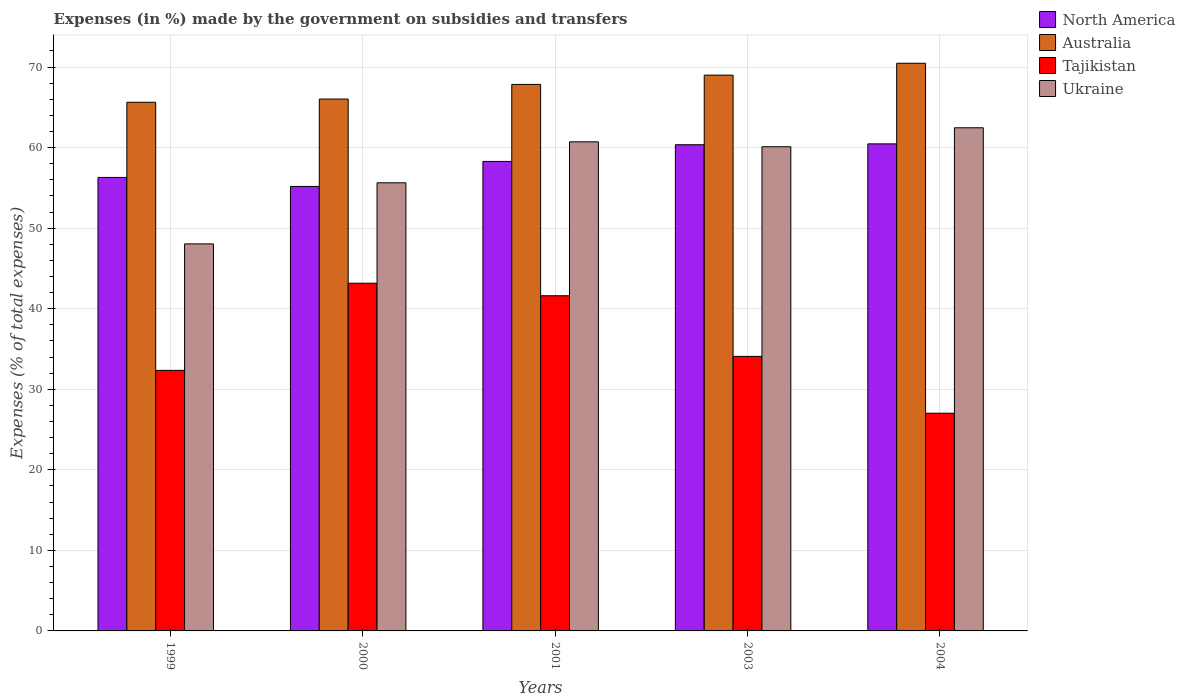In how many cases, is the number of bars for a given year not equal to the number of legend labels?
Ensure brevity in your answer.  0. What is the percentage of expenses made by the government on subsidies and transfers in Tajikistan in 2004?
Offer a very short reply. 27.03. Across all years, what is the maximum percentage of expenses made by the government on subsidies and transfers in Tajikistan?
Give a very brief answer. 43.16. Across all years, what is the minimum percentage of expenses made by the government on subsidies and transfers in Tajikistan?
Keep it short and to the point. 27.03. In which year was the percentage of expenses made by the government on subsidies and transfers in Tajikistan maximum?
Offer a very short reply. 2000. What is the total percentage of expenses made by the government on subsidies and transfers in Tajikistan in the graph?
Keep it short and to the point. 178.21. What is the difference between the percentage of expenses made by the government on subsidies and transfers in Tajikistan in 2003 and that in 2004?
Your response must be concise. 7.05. What is the difference between the percentage of expenses made by the government on subsidies and transfers in Tajikistan in 2003 and the percentage of expenses made by the government on subsidies and transfers in Ukraine in 1999?
Provide a succinct answer. -13.97. What is the average percentage of expenses made by the government on subsidies and transfers in North America per year?
Offer a terse response. 58.11. In the year 2004, what is the difference between the percentage of expenses made by the government on subsidies and transfers in Ukraine and percentage of expenses made by the government on subsidies and transfers in North America?
Your answer should be very brief. 2. In how many years, is the percentage of expenses made by the government on subsidies and transfers in North America greater than 40 %?
Make the answer very short. 5. What is the ratio of the percentage of expenses made by the government on subsidies and transfers in Australia in 1999 to that in 2000?
Your answer should be very brief. 0.99. What is the difference between the highest and the second highest percentage of expenses made by the government on subsidies and transfers in Tajikistan?
Give a very brief answer. 1.56. What is the difference between the highest and the lowest percentage of expenses made by the government on subsidies and transfers in Tajikistan?
Provide a short and direct response. 16.14. Is the sum of the percentage of expenses made by the government on subsidies and transfers in North America in 1999 and 2003 greater than the maximum percentage of expenses made by the government on subsidies and transfers in Australia across all years?
Offer a very short reply. Yes. What does the 4th bar from the left in 2001 represents?
Make the answer very short. Ukraine. What does the 2nd bar from the right in 2004 represents?
Ensure brevity in your answer.  Tajikistan. Is it the case that in every year, the sum of the percentage of expenses made by the government on subsidies and transfers in North America and percentage of expenses made by the government on subsidies and transfers in Australia is greater than the percentage of expenses made by the government on subsidies and transfers in Tajikistan?
Offer a terse response. Yes. How many bars are there?
Ensure brevity in your answer.  20. How many years are there in the graph?
Keep it short and to the point. 5. What is the difference between two consecutive major ticks on the Y-axis?
Your answer should be very brief. 10. Are the values on the major ticks of Y-axis written in scientific E-notation?
Ensure brevity in your answer.  No. Does the graph contain grids?
Ensure brevity in your answer.  Yes. How are the legend labels stacked?
Give a very brief answer. Vertical. What is the title of the graph?
Provide a succinct answer. Expenses (in %) made by the government on subsidies and transfers. Does "Namibia" appear as one of the legend labels in the graph?
Offer a terse response. No. What is the label or title of the Y-axis?
Give a very brief answer. Expenses (% of total expenses). What is the Expenses (% of total expenses) of North America in 1999?
Your answer should be compact. 56.29. What is the Expenses (% of total expenses) of Australia in 1999?
Your response must be concise. 65.63. What is the Expenses (% of total expenses) of Tajikistan in 1999?
Give a very brief answer. 32.34. What is the Expenses (% of total expenses) in Ukraine in 1999?
Ensure brevity in your answer.  48.04. What is the Expenses (% of total expenses) of North America in 2000?
Give a very brief answer. 55.18. What is the Expenses (% of total expenses) of Australia in 2000?
Give a very brief answer. 66.02. What is the Expenses (% of total expenses) of Tajikistan in 2000?
Provide a short and direct response. 43.16. What is the Expenses (% of total expenses) of Ukraine in 2000?
Offer a very short reply. 55.63. What is the Expenses (% of total expenses) of North America in 2001?
Make the answer very short. 58.28. What is the Expenses (% of total expenses) of Australia in 2001?
Offer a very short reply. 67.84. What is the Expenses (% of total expenses) in Tajikistan in 2001?
Provide a short and direct response. 41.61. What is the Expenses (% of total expenses) in Ukraine in 2001?
Make the answer very short. 60.71. What is the Expenses (% of total expenses) in North America in 2003?
Ensure brevity in your answer.  60.35. What is the Expenses (% of total expenses) of Australia in 2003?
Ensure brevity in your answer.  68.99. What is the Expenses (% of total expenses) in Tajikistan in 2003?
Give a very brief answer. 34.08. What is the Expenses (% of total expenses) in Ukraine in 2003?
Your answer should be compact. 60.1. What is the Expenses (% of total expenses) in North America in 2004?
Offer a very short reply. 60.46. What is the Expenses (% of total expenses) in Australia in 2004?
Give a very brief answer. 70.47. What is the Expenses (% of total expenses) in Tajikistan in 2004?
Keep it short and to the point. 27.03. What is the Expenses (% of total expenses) of Ukraine in 2004?
Your answer should be very brief. 62.46. Across all years, what is the maximum Expenses (% of total expenses) of North America?
Provide a short and direct response. 60.46. Across all years, what is the maximum Expenses (% of total expenses) in Australia?
Ensure brevity in your answer.  70.47. Across all years, what is the maximum Expenses (% of total expenses) of Tajikistan?
Offer a terse response. 43.16. Across all years, what is the maximum Expenses (% of total expenses) of Ukraine?
Give a very brief answer. 62.46. Across all years, what is the minimum Expenses (% of total expenses) in North America?
Offer a terse response. 55.18. Across all years, what is the minimum Expenses (% of total expenses) in Australia?
Provide a short and direct response. 65.63. Across all years, what is the minimum Expenses (% of total expenses) in Tajikistan?
Your answer should be very brief. 27.03. Across all years, what is the minimum Expenses (% of total expenses) of Ukraine?
Provide a succinct answer. 48.04. What is the total Expenses (% of total expenses) in North America in the graph?
Provide a short and direct response. 290.56. What is the total Expenses (% of total expenses) in Australia in the graph?
Your answer should be compact. 338.95. What is the total Expenses (% of total expenses) of Tajikistan in the graph?
Give a very brief answer. 178.21. What is the total Expenses (% of total expenses) in Ukraine in the graph?
Offer a very short reply. 286.95. What is the difference between the Expenses (% of total expenses) of North America in 1999 and that in 2000?
Make the answer very short. 1.12. What is the difference between the Expenses (% of total expenses) of Australia in 1999 and that in 2000?
Ensure brevity in your answer.  -0.4. What is the difference between the Expenses (% of total expenses) of Tajikistan in 1999 and that in 2000?
Give a very brief answer. -10.82. What is the difference between the Expenses (% of total expenses) of Ukraine in 1999 and that in 2000?
Keep it short and to the point. -7.59. What is the difference between the Expenses (% of total expenses) of North America in 1999 and that in 2001?
Offer a very short reply. -1.99. What is the difference between the Expenses (% of total expenses) of Australia in 1999 and that in 2001?
Keep it short and to the point. -2.21. What is the difference between the Expenses (% of total expenses) of Tajikistan in 1999 and that in 2001?
Your answer should be compact. -9.27. What is the difference between the Expenses (% of total expenses) of Ukraine in 1999 and that in 2001?
Give a very brief answer. -12.67. What is the difference between the Expenses (% of total expenses) of North America in 1999 and that in 2003?
Keep it short and to the point. -4.06. What is the difference between the Expenses (% of total expenses) in Australia in 1999 and that in 2003?
Your response must be concise. -3.37. What is the difference between the Expenses (% of total expenses) of Tajikistan in 1999 and that in 2003?
Your answer should be compact. -1.74. What is the difference between the Expenses (% of total expenses) of Ukraine in 1999 and that in 2003?
Make the answer very short. -12.06. What is the difference between the Expenses (% of total expenses) in North America in 1999 and that in 2004?
Provide a short and direct response. -4.17. What is the difference between the Expenses (% of total expenses) of Australia in 1999 and that in 2004?
Your response must be concise. -4.84. What is the difference between the Expenses (% of total expenses) of Tajikistan in 1999 and that in 2004?
Your response must be concise. 5.32. What is the difference between the Expenses (% of total expenses) of Ukraine in 1999 and that in 2004?
Your answer should be compact. -14.41. What is the difference between the Expenses (% of total expenses) of North America in 2000 and that in 2001?
Your response must be concise. -3.1. What is the difference between the Expenses (% of total expenses) of Australia in 2000 and that in 2001?
Ensure brevity in your answer.  -1.82. What is the difference between the Expenses (% of total expenses) in Tajikistan in 2000 and that in 2001?
Provide a short and direct response. 1.56. What is the difference between the Expenses (% of total expenses) of Ukraine in 2000 and that in 2001?
Provide a succinct answer. -5.08. What is the difference between the Expenses (% of total expenses) in North America in 2000 and that in 2003?
Provide a succinct answer. -5.18. What is the difference between the Expenses (% of total expenses) in Australia in 2000 and that in 2003?
Keep it short and to the point. -2.97. What is the difference between the Expenses (% of total expenses) of Tajikistan in 2000 and that in 2003?
Your response must be concise. 9.09. What is the difference between the Expenses (% of total expenses) of Ukraine in 2000 and that in 2003?
Offer a terse response. -4.47. What is the difference between the Expenses (% of total expenses) in North America in 2000 and that in 2004?
Your answer should be compact. -5.29. What is the difference between the Expenses (% of total expenses) in Australia in 2000 and that in 2004?
Your answer should be compact. -4.44. What is the difference between the Expenses (% of total expenses) in Tajikistan in 2000 and that in 2004?
Make the answer very short. 16.14. What is the difference between the Expenses (% of total expenses) in Ukraine in 2000 and that in 2004?
Give a very brief answer. -6.83. What is the difference between the Expenses (% of total expenses) of North America in 2001 and that in 2003?
Your response must be concise. -2.07. What is the difference between the Expenses (% of total expenses) in Australia in 2001 and that in 2003?
Keep it short and to the point. -1.15. What is the difference between the Expenses (% of total expenses) of Tajikistan in 2001 and that in 2003?
Provide a succinct answer. 7.53. What is the difference between the Expenses (% of total expenses) in Ukraine in 2001 and that in 2003?
Your answer should be compact. 0.61. What is the difference between the Expenses (% of total expenses) in North America in 2001 and that in 2004?
Your response must be concise. -2.18. What is the difference between the Expenses (% of total expenses) in Australia in 2001 and that in 2004?
Your answer should be compact. -2.63. What is the difference between the Expenses (% of total expenses) in Tajikistan in 2001 and that in 2004?
Ensure brevity in your answer.  14.58. What is the difference between the Expenses (% of total expenses) in Ukraine in 2001 and that in 2004?
Your answer should be very brief. -1.75. What is the difference between the Expenses (% of total expenses) of North America in 2003 and that in 2004?
Ensure brevity in your answer.  -0.11. What is the difference between the Expenses (% of total expenses) in Australia in 2003 and that in 2004?
Offer a terse response. -1.47. What is the difference between the Expenses (% of total expenses) in Tajikistan in 2003 and that in 2004?
Offer a very short reply. 7.05. What is the difference between the Expenses (% of total expenses) in Ukraine in 2003 and that in 2004?
Make the answer very short. -2.36. What is the difference between the Expenses (% of total expenses) in North America in 1999 and the Expenses (% of total expenses) in Australia in 2000?
Your response must be concise. -9.73. What is the difference between the Expenses (% of total expenses) of North America in 1999 and the Expenses (% of total expenses) of Tajikistan in 2000?
Provide a succinct answer. 13.13. What is the difference between the Expenses (% of total expenses) of North America in 1999 and the Expenses (% of total expenses) of Ukraine in 2000?
Keep it short and to the point. 0.66. What is the difference between the Expenses (% of total expenses) of Australia in 1999 and the Expenses (% of total expenses) of Tajikistan in 2000?
Keep it short and to the point. 22.46. What is the difference between the Expenses (% of total expenses) in Australia in 1999 and the Expenses (% of total expenses) in Ukraine in 2000?
Give a very brief answer. 10. What is the difference between the Expenses (% of total expenses) in Tajikistan in 1999 and the Expenses (% of total expenses) in Ukraine in 2000?
Keep it short and to the point. -23.29. What is the difference between the Expenses (% of total expenses) of North America in 1999 and the Expenses (% of total expenses) of Australia in 2001?
Make the answer very short. -11.55. What is the difference between the Expenses (% of total expenses) in North America in 1999 and the Expenses (% of total expenses) in Tajikistan in 2001?
Provide a short and direct response. 14.69. What is the difference between the Expenses (% of total expenses) in North America in 1999 and the Expenses (% of total expenses) in Ukraine in 2001?
Give a very brief answer. -4.42. What is the difference between the Expenses (% of total expenses) in Australia in 1999 and the Expenses (% of total expenses) in Tajikistan in 2001?
Provide a short and direct response. 24.02. What is the difference between the Expenses (% of total expenses) of Australia in 1999 and the Expenses (% of total expenses) of Ukraine in 2001?
Offer a very short reply. 4.91. What is the difference between the Expenses (% of total expenses) in Tajikistan in 1999 and the Expenses (% of total expenses) in Ukraine in 2001?
Provide a succinct answer. -28.37. What is the difference between the Expenses (% of total expenses) in North America in 1999 and the Expenses (% of total expenses) in Australia in 2003?
Offer a terse response. -12.7. What is the difference between the Expenses (% of total expenses) of North America in 1999 and the Expenses (% of total expenses) of Tajikistan in 2003?
Your answer should be compact. 22.22. What is the difference between the Expenses (% of total expenses) in North America in 1999 and the Expenses (% of total expenses) in Ukraine in 2003?
Ensure brevity in your answer.  -3.81. What is the difference between the Expenses (% of total expenses) in Australia in 1999 and the Expenses (% of total expenses) in Tajikistan in 2003?
Offer a very short reply. 31.55. What is the difference between the Expenses (% of total expenses) in Australia in 1999 and the Expenses (% of total expenses) in Ukraine in 2003?
Your answer should be compact. 5.52. What is the difference between the Expenses (% of total expenses) in Tajikistan in 1999 and the Expenses (% of total expenses) in Ukraine in 2003?
Your response must be concise. -27.76. What is the difference between the Expenses (% of total expenses) of North America in 1999 and the Expenses (% of total expenses) of Australia in 2004?
Your answer should be compact. -14.17. What is the difference between the Expenses (% of total expenses) in North America in 1999 and the Expenses (% of total expenses) in Tajikistan in 2004?
Ensure brevity in your answer.  29.27. What is the difference between the Expenses (% of total expenses) of North America in 1999 and the Expenses (% of total expenses) of Ukraine in 2004?
Give a very brief answer. -6.17. What is the difference between the Expenses (% of total expenses) of Australia in 1999 and the Expenses (% of total expenses) of Tajikistan in 2004?
Offer a very short reply. 38.6. What is the difference between the Expenses (% of total expenses) of Australia in 1999 and the Expenses (% of total expenses) of Ukraine in 2004?
Your answer should be very brief. 3.17. What is the difference between the Expenses (% of total expenses) of Tajikistan in 1999 and the Expenses (% of total expenses) of Ukraine in 2004?
Provide a succinct answer. -30.12. What is the difference between the Expenses (% of total expenses) in North America in 2000 and the Expenses (% of total expenses) in Australia in 2001?
Your answer should be compact. -12.67. What is the difference between the Expenses (% of total expenses) in North America in 2000 and the Expenses (% of total expenses) in Tajikistan in 2001?
Your answer should be compact. 13.57. What is the difference between the Expenses (% of total expenses) of North America in 2000 and the Expenses (% of total expenses) of Ukraine in 2001?
Provide a short and direct response. -5.54. What is the difference between the Expenses (% of total expenses) in Australia in 2000 and the Expenses (% of total expenses) in Tajikistan in 2001?
Make the answer very short. 24.42. What is the difference between the Expenses (% of total expenses) of Australia in 2000 and the Expenses (% of total expenses) of Ukraine in 2001?
Provide a short and direct response. 5.31. What is the difference between the Expenses (% of total expenses) in Tajikistan in 2000 and the Expenses (% of total expenses) in Ukraine in 2001?
Keep it short and to the point. -17.55. What is the difference between the Expenses (% of total expenses) of North America in 2000 and the Expenses (% of total expenses) of Australia in 2003?
Offer a very short reply. -13.82. What is the difference between the Expenses (% of total expenses) of North America in 2000 and the Expenses (% of total expenses) of Tajikistan in 2003?
Make the answer very short. 21.1. What is the difference between the Expenses (% of total expenses) in North America in 2000 and the Expenses (% of total expenses) in Ukraine in 2003?
Provide a succinct answer. -4.93. What is the difference between the Expenses (% of total expenses) in Australia in 2000 and the Expenses (% of total expenses) in Tajikistan in 2003?
Keep it short and to the point. 31.95. What is the difference between the Expenses (% of total expenses) of Australia in 2000 and the Expenses (% of total expenses) of Ukraine in 2003?
Give a very brief answer. 5.92. What is the difference between the Expenses (% of total expenses) in Tajikistan in 2000 and the Expenses (% of total expenses) in Ukraine in 2003?
Your response must be concise. -16.94. What is the difference between the Expenses (% of total expenses) in North America in 2000 and the Expenses (% of total expenses) in Australia in 2004?
Make the answer very short. -15.29. What is the difference between the Expenses (% of total expenses) in North America in 2000 and the Expenses (% of total expenses) in Tajikistan in 2004?
Your answer should be very brief. 28.15. What is the difference between the Expenses (% of total expenses) of North America in 2000 and the Expenses (% of total expenses) of Ukraine in 2004?
Your answer should be very brief. -7.28. What is the difference between the Expenses (% of total expenses) of Australia in 2000 and the Expenses (% of total expenses) of Tajikistan in 2004?
Your answer should be very brief. 39. What is the difference between the Expenses (% of total expenses) of Australia in 2000 and the Expenses (% of total expenses) of Ukraine in 2004?
Offer a terse response. 3.57. What is the difference between the Expenses (% of total expenses) of Tajikistan in 2000 and the Expenses (% of total expenses) of Ukraine in 2004?
Make the answer very short. -19.3. What is the difference between the Expenses (% of total expenses) in North America in 2001 and the Expenses (% of total expenses) in Australia in 2003?
Ensure brevity in your answer.  -10.71. What is the difference between the Expenses (% of total expenses) in North America in 2001 and the Expenses (% of total expenses) in Tajikistan in 2003?
Provide a short and direct response. 24.2. What is the difference between the Expenses (% of total expenses) in North America in 2001 and the Expenses (% of total expenses) in Ukraine in 2003?
Make the answer very short. -1.82. What is the difference between the Expenses (% of total expenses) in Australia in 2001 and the Expenses (% of total expenses) in Tajikistan in 2003?
Ensure brevity in your answer.  33.76. What is the difference between the Expenses (% of total expenses) of Australia in 2001 and the Expenses (% of total expenses) of Ukraine in 2003?
Offer a very short reply. 7.74. What is the difference between the Expenses (% of total expenses) of Tajikistan in 2001 and the Expenses (% of total expenses) of Ukraine in 2003?
Provide a short and direct response. -18.5. What is the difference between the Expenses (% of total expenses) of North America in 2001 and the Expenses (% of total expenses) of Australia in 2004?
Give a very brief answer. -12.19. What is the difference between the Expenses (% of total expenses) in North America in 2001 and the Expenses (% of total expenses) in Tajikistan in 2004?
Offer a very short reply. 31.25. What is the difference between the Expenses (% of total expenses) of North America in 2001 and the Expenses (% of total expenses) of Ukraine in 2004?
Provide a short and direct response. -4.18. What is the difference between the Expenses (% of total expenses) in Australia in 2001 and the Expenses (% of total expenses) in Tajikistan in 2004?
Your answer should be compact. 40.81. What is the difference between the Expenses (% of total expenses) of Australia in 2001 and the Expenses (% of total expenses) of Ukraine in 2004?
Make the answer very short. 5.38. What is the difference between the Expenses (% of total expenses) in Tajikistan in 2001 and the Expenses (% of total expenses) in Ukraine in 2004?
Your answer should be compact. -20.85. What is the difference between the Expenses (% of total expenses) of North America in 2003 and the Expenses (% of total expenses) of Australia in 2004?
Provide a short and direct response. -10.11. What is the difference between the Expenses (% of total expenses) in North America in 2003 and the Expenses (% of total expenses) in Tajikistan in 2004?
Offer a very short reply. 33.33. What is the difference between the Expenses (% of total expenses) in North America in 2003 and the Expenses (% of total expenses) in Ukraine in 2004?
Keep it short and to the point. -2.11. What is the difference between the Expenses (% of total expenses) in Australia in 2003 and the Expenses (% of total expenses) in Tajikistan in 2004?
Give a very brief answer. 41.97. What is the difference between the Expenses (% of total expenses) of Australia in 2003 and the Expenses (% of total expenses) of Ukraine in 2004?
Offer a terse response. 6.53. What is the difference between the Expenses (% of total expenses) in Tajikistan in 2003 and the Expenses (% of total expenses) in Ukraine in 2004?
Provide a succinct answer. -28.38. What is the average Expenses (% of total expenses) of North America per year?
Offer a very short reply. 58.11. What is the average Expenses (% of total expenses) in Australia per year?
Provide a succinct answer. 67.79. What is the average Expenses (% of total expenses) of Tajikistan per year?
Provide a succinct answer. 35.64. What is the average Expenses (% of total expenses) of Ukraine per year?
Offer a terse response. 57.39. In the year 1999, what is the difference between the Expenses (% of total expenses) in North America and Expenses (% of total expenses) in Australia?
Offer a terse response. -9.33. In the year 1999, what is the difference between the Expenses (% of total expenses) in North America and Expenses (% of total expenses) in Tajikistan?
Provide a succinct answer. 23.95. In the year 1999, what is the difference between the Expenses (% of total expenses) in North America and Expenses (% of total expenses) in Ukraine?
Your answer should be compact. 8.25. In the year 1999, what is the difference between the Expenses (% of total expenses) in Australia and Expenses (% of total expenses) in Tajikistan?
Ensure brevity in your answer.  33.28. In the year 1999, what is the difference between the Expenses (% of total expenses) of Australia and Expenses (% of total expenses) of Ukraine?
Offer a very short reply. 17.58. In the year 1999, what is the difference between the Expenses (% of total expenses) in Tajikistan and Expenses (% of total expenses) in Ukraine?
Give a very brief answer. -15.7. In the year 2000, what is the difference between the Expenses (% of total expenses) in North America and Expenses (% of total expenses) in Australia?
Offer a terse response. -10.85. In the year 2000, what is the difference between the Expenses (% of total expenses) of North America and Expenses (% of total expenses) of Tajikistan?
Your answer should be compact. 12.01. In the year 2000, what is the difference between the Expenses (% of total expenses) in North America and Expenses (% of total expenses) in Ukraine?
Your answer should be compact. -0.45. In the year 2000, what is the difference between the Expenses (% of total expenses) of Australia and Expenses (% of total expenses) of Tajikistan?
Your answer should be very brief. 22.86. In the year 2000, what is the difference between the Expenses (% of total expenses) in Australia and Expenses (% of total expenses) in Ukraine?
Your response must be concise. 10.39. In the year 2000, what is the difference between the Expenses (% of total expenses) of Tajikistan and Expenses (% of total expenses) of Ukraine?
Make the answer very short. -12.47. In the year 2001, what is the difference between the Expenses (% of total expenses) of North America and Expenses (% of total expenses) of Australia?
Your answer should be compact. -9.56. In the year 2001, what is the difference between the Expenses (% of total expenses) of North America and Expenses (% of total expenses) of Tajikistan?
Provide a succinct answer. 16.67. In the year 2001, what is the difference between the Expenses (% of total expenses) of North America and Expenses (% of total expenses) of Ukraine?
Ensure brevity in your answer.  -2.43. In the year 2001, what is the difference between the Expenses (% of total expenses) of Australia and Expenses (% of total expenses) of Tajikistan?
Offer a very short reply. 26.23. In the year 2001, what is the difference between the Expenses (% of total expenses) of Australia and Expenses (% of total expenses) of Ukraine?
Give a very brief answer. 7.13. In the year 2001, what is the difference between the Expenses (% of total expenses) of Tajikistan and Expenses (% of total expenses) of Ukraine?
Give a very brief answer. -19.1. In the year 2003, what is the difference between the Expenses (% of total expenses) of North America and Expenses (% of total expenses) of Australia?
Your answer should be compact. -8.64. In the year 2003, what is the difference between the Expenses (% of total expenses) of North America and Expenses (% of total expenses) of Tajikistan?
Keep it short and to the point. 26.28. In the year 2003, what is the difference between the Expenses (% of total expenses) in North America and Expenses (% of total expenses) in Ukraine?
Your answer should be very brief. 0.25. In the year 2003, what is the difference between the Expenses (% of total expenses) in Australia and Expenses (% of total expenses) in Tajikistan?
Provide a succinct answer. 34.92. In the year 2003, what is the difference between the Expenses (% of total expenses) of Australia and Expenses (% of total expenses) of Ukraine?
Offer a terse response. 8.89. In the year 2003, what is the difference between the Expenses (% of total expenses) in Tajikistan and Expenses (% of total expenses) in Ukraine?
Keep it short and to the point. -26.03. In the year 2004, what is the difference between the Expenses (% of total expenses) in North America and Expenses (% of total expenses) in Australia?
Your answer should be compact. -10.01. In the year 2004, what is the difference between the Expenses (% of total expenses) of North America and Expenses (% of total expenses) of Tajikistan?
Your answer should be very brief. 33.43. In the year 2004, what is the difference between the Expenses (% of total expenses) in North America and Expenses (% of total expenses) in Ukraine?
Offer a terse response. -2. In the year 2004, what is the difference between the Expenses (% of total expenses) of Australia and Expenses (% of total expenses) of Tajikistan?
Offer a terse response. 43.44. In the year 2004, what is the difference between the Expenses (% of total expenses) of Australia and Expenses (% of total expenses) of Ukraine?
Ensure brevity in your answer.  8.01. In the year 2004, what is the difference between the Expenses (% of total expenses) of Tajikistan and Expenses (% of total expenses) of Ukraine?
Your answer should be very brief. -35.43. What is the ratio of the Expenses (% of total expenses) of North America in 1999 to that in 2000?
Your response must be concise. 1.02. What is the ratio of the Expenses (% of total expenses) of Tajikistan in 1999 to that in 2000?
Your answer should be very brief. 0.75. What is the ratio of the Expenses (% of total expenses) in Ukraine in 1999 to that in 2000?
Provide a succinct answer. 0.86. What is the ratio of the Expenses (% of total expenses) of North America in 1999 to that in 2001?
Offer a very short reply. 0.97. What is the ratio of the Expenses (% of total expenses) in Australia in 1999 to that in 2001?
Make the answer very short. 0.97. What is the ratio of the Expenses (% of total expenses) in Tajikistan in 1999 to that in 2001?
Give a very brief answer. 0.78. What is the ratio of the Expenses (% of total expenses) in Ukraine in 1999 to that in 2001?
Your answer should be compact. 0.79. What is the ratio of the Expenses (% of total expenses) in North America in 1999 to that in 2003?
Your answer should be very brief. 0.93. What is the ratio of the Expenses (% of total expenses) in Australia in 1999 to that in 2003?
Make the answer very short. 0.95. What is the ratio of the Expenses (% of total expenses) of Tajikistan in 1999 to that in 2003?
Give a very brief answer. 0.95. What is the ratio of the Expenses (% of total expenses) in Ukraine in 1999 to that in 2003?
Ensure brevity in your answer.  0.8. What is the ratio of the Expenses (% of total expenses) in North America in 1999 to that in 2004?
Give a very brief answer. 0.93. What is the ratio of the Expenses (% of total expenses) of Australia in 1999 to that in 2004?
Your answer should be compact. 0.93. What is the ratio of the Expenses (% of total expenses) in Tajikistan in 1999 to that in 2004?
Make the answer very short. 1.2. What is the ratio of the Expenses (% of total expenses) in Ukraine in 1999 to that in 2004?
Give a very brief answer. 0.77. What is the ratio of the Expenses (% of total expenses) in North America in 2000 to that in 2001?
Your response must be concise. 0.95. What is the ratio of the Expenses (% of total expenses) of Australia in 2000 to that in 2001?
Keep it short and to the point. 0.97. What is the ratio of the Expenses (% of total expenses) of Tajikistan in 2000 to that in 2001?
Ensure brevity in your answer.  1.04. What is the ratio of the Expenses (% of total expenses) in Ukraine in 2000 to that in 2001?
Ensure brevity in your answer.  0.92. What is the ratio of the Expenses (% of total expenses) in North America in 2000 to that in 2003?
Provide a succinct answer. 0.91. What is the ratio of the Expenses (% of total expenses) in Australia in 2000 to that in 2003?
Keep it short and to the point. 0.96. What is the ratio of the Expenses (% of total expenses) in Tajikistan in 2000 to that in 2003?
Make the answer very short. 1.27. What is the ratio of the Expenses (% of total expenses) in Ukraine in 2000 to that in 2003?
Your answer should be very brief. 0.93. What is the ratio of the Expenses (% of total expenses) of North America in 2000 to that in 2004?
Provide a short and direct response. 0.91. What is the ratio of the Expenses (% of total expenses) of Australia in 2000 to that in 2004?
Your answer should be compact. 0.94. What is the ratio of the Expenses (% of total expenses) of Tajikistan in 2000 to that in 2004?
Give a very brief answer. 1.6. What is the ratio of the Expenses (% of total expenses) of Ukraine in 2000 to that in 2004?
Offer a terse response. 0.89. What is the ratio of the Expenses (% of total expenses) in North America in 2001 to that in 2003?
Make the answer very short. 0.97. What is the ratio of the Expenses (% of total expenses) of Australia in 2001 to that in 2003?
Your response must be concise. 0.98. What is the ratio of the Expenses (% of total expenses) of Tajikistan in 2001 to that in 2003?
Provide a short and direct response. 1.22. What is the ratio of the Expenses (% of total expenses) of North America in 2001 to that in 2004?
Keep it short and to the point. 0.96. What is the ratio of the Expenses (% of total expenses) of Australia in 2001 to that in 2004?
Ensure brevity in your answer.  0.96. What is the ratio of the Expenses (% of total expenses) in Tajikistan in 2001 to that in 2004?
Your response must be concise. 1.54. What is the ratio of the Expenses (% of total expenses) of North America in 2003 to that in 2004?
Offer a terse response. 1. What is the ratio of the Expenses (% of total expenses) in Australia in 2003 to that in 2004?
Your answer should be very brief. 0.98. What is the ratio of the Expenses (% of total expenses) of Tajikistan in 2003 to that in 2004?
Offer a very short reply. 1.26. What is the ratio of the Expenses (% of total expenses) of Ukraine in 2003 to that in 2004?
Your response must be concise. 0.96. What is the difference between the highest and the second highest Expenses (% of total expenses) of North America?
Your response must be concise. 0.11. What is the difference between the highest and the second highest Expenses (% of total expenses) in Australia?
Make the answer very short. 1.47. What is the difference between the highest and the second highest Expenses (% of total expenses) of Tajikistan?
Give a very brief answer. 1.56. What is the difference between the highest and the second highest Expenses (% of total expenses) in Ukraine?
Ensure brevity in your answer.  1.75. What is the difference between the highest and the lowest Expenses (% of total expenses) in North America?
Offer a very short reply. 5.29. What is the difference between the highest and the lowest Expenses (% of total expenses) in Australia?
Provide a succinct answer. 4.84. What is the difference between the highest and the lowest Expenses (% of total expenses) of Tajikistan?
Provide a short and direct response. 16.14. What is the difference between the highest and the lowest Expenses (% of total expenses) in Ukraine?
Offer a terse response. 14.41. 